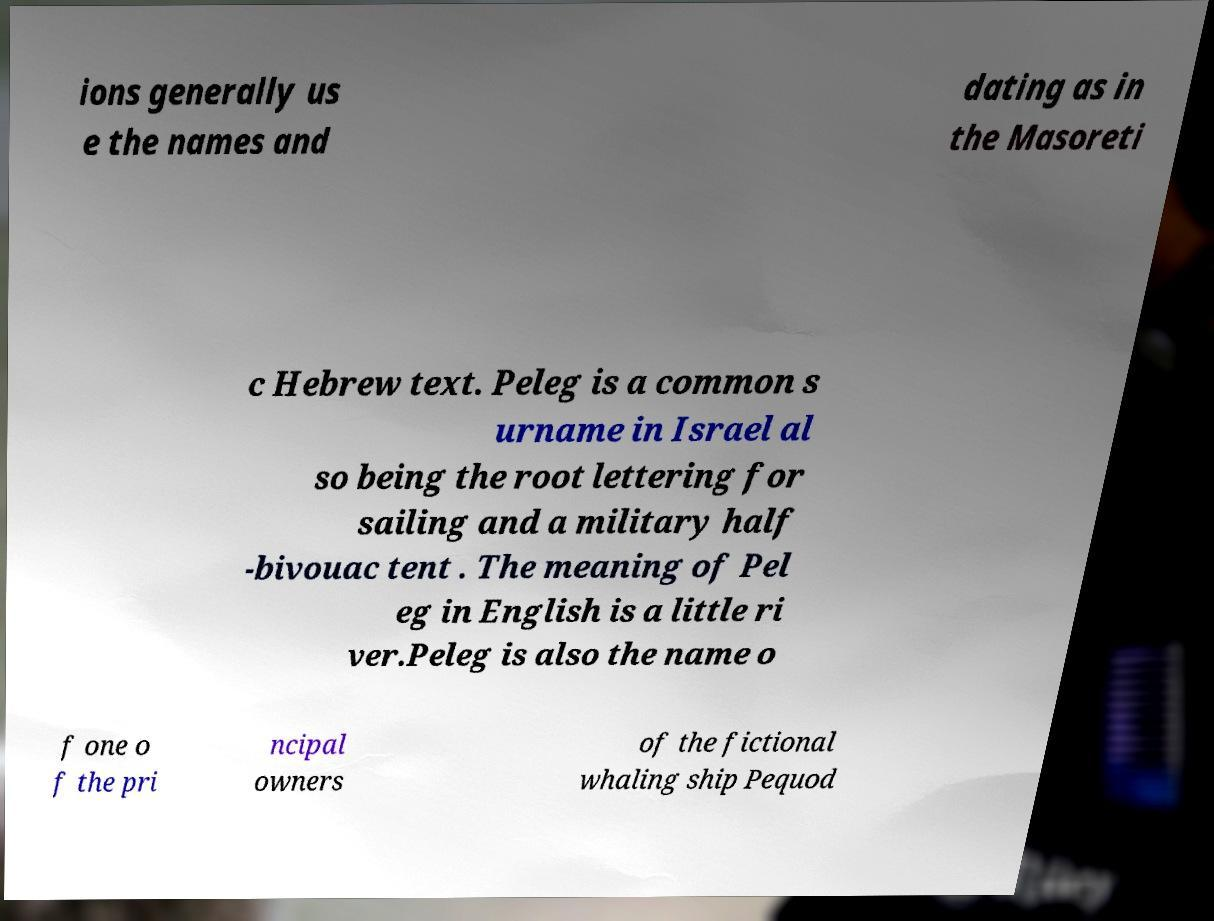Could you extract and type out the text from this image? ions generally us e the names and dating as in the Masoreti c Hebrew text. Peleg is a common s urname in Israel al so being the root lettering for sailing and a military half -bivouac tent . The meaning of Pel eg in English is a little ri ver.Peleg is also the name o f one o f the pri ncipal owners of the fictional whaling ship Pequod 